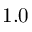<formula> <loc_0><loc_0><loc_500><loc_500>1 . 0</formula> 